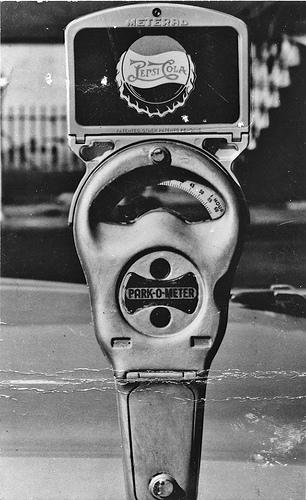What company is advertised?
Keep it brief. Pepsi. What does this device do?
Concise answer only. Parking meter. Is that a parking meter?
Give a very brief answer. Yes. 